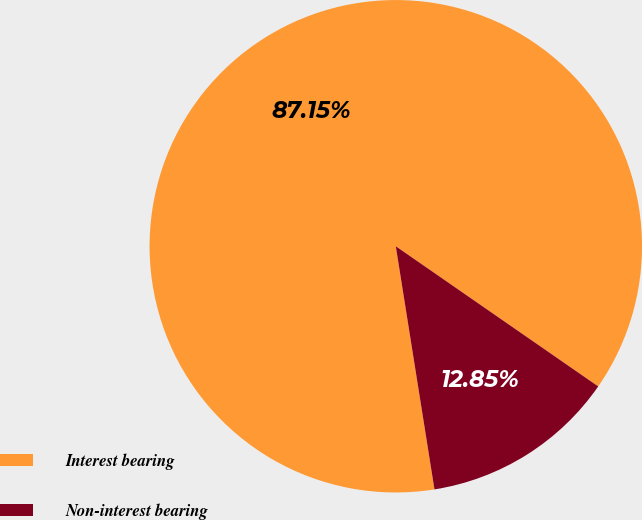Convert chart. <chart><loc_0><loc_0><loc_500><loc_500><pie_chart><fcel>Interest bearing<fcel>Non-interest bearing<nl><fcel>87.15%<fcel>12.85%<nl></chart> 